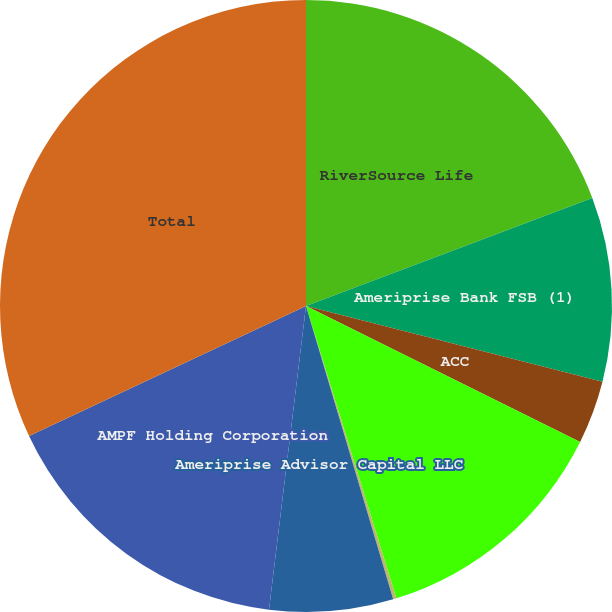Convert chart to OTSL. <chart><loc_0><loc_0><loc_500><loc_500><pie_chart><fcel>RiverSource Life<fcel>Ameriprise Bank FSB (1)<fcel>ACC<fcel>Columbia Management Investment<fcel>Ameriprise Trust Company<fcel>Ameriprise Advisor Capital LLC<fcel>AMPF Holding Corporation<fcel>Total<nl><fcel>19.26%<fcel>9.72%<fcel>3.35%<fcel>12.9%<fcel>0.17%<fcel>6.53%<fcel>16.08%<fcel>31.99%<nl></chart> 